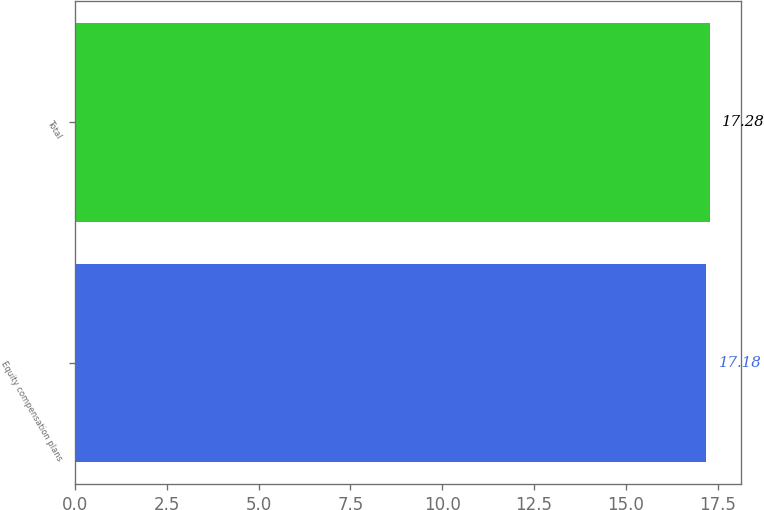Convert chart. <chart><loc_0><loc_0><loc_500><loc_500><bar_chart><fcel>Equity compensation plans<fcel>Total<nl><fcel>17.18<fcel>17.28<nl></chart> 